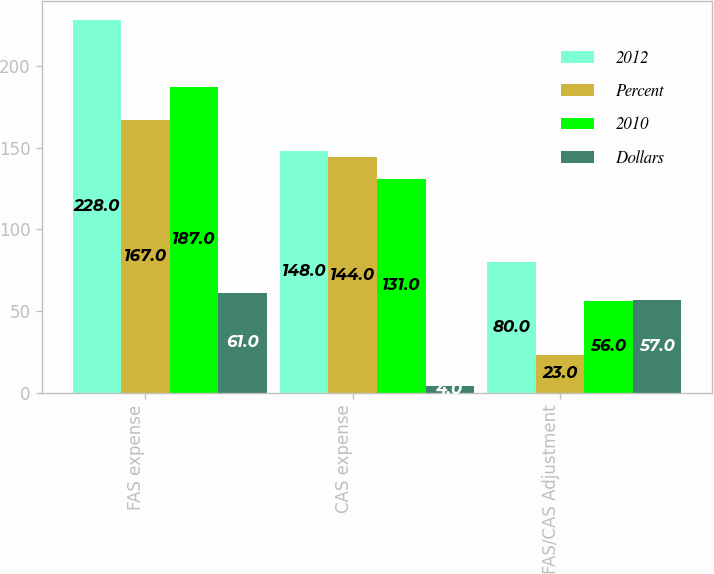<chart> <loc_0><loc_0><loc_500><loc_500><stacked_bar_chart><ecel><fcel>FAS expense<fcel>CAS expense<fcel>FAS/CAS Adjustment<nl><fcel>2012<fcel>228<fcel>148<fcel>80<nl><fcel>Percent<fcel>167<fcel>144<fcel>23<nl><fcel>2010<fcel>187<fcel>131<fcel>56<nl><fcel>Dollars<fcel>61<fcel>4<fcel>57<nl></chart> 